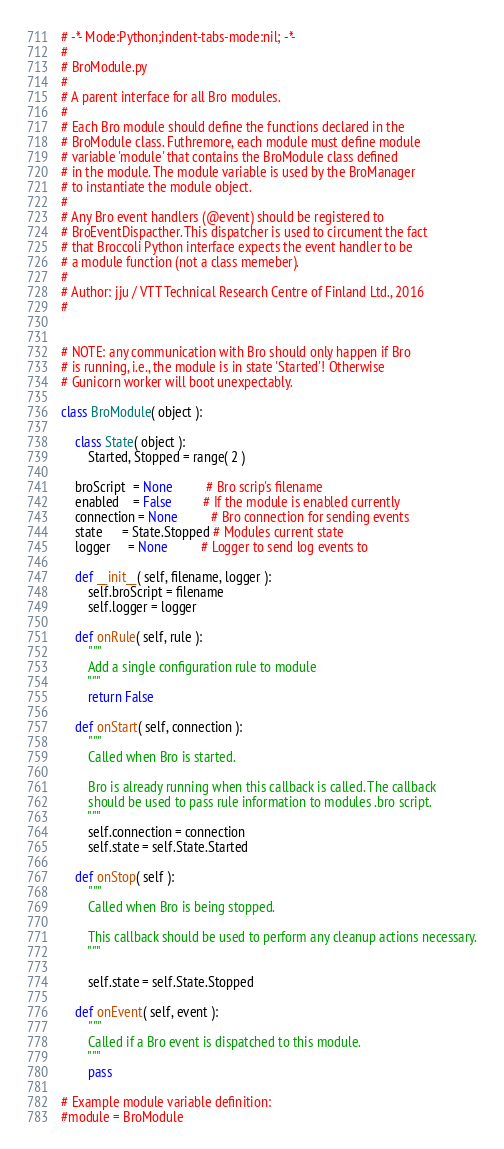Convert code to text. <code><loc_0><loc_0><loc_500><loc_500><_Python_># -*- Mode:Python;indent-tabs-mode:nil; -*-
#
# BroModule.py
#
# A parent interface for all Bro modules.
#
# Each Bro module should define the functions declared in the
# BroModule class. Futhremore, each module must define module
# variable 'module' that contains the BroModule class defined
# in the module. The module variable is used by the BroManager
# to instantiate the module object.
#
# Any Bro event handlers (@event) should be registered to
# BroEventDispacther. This dispatcher is used to circument the fact
# that Broccoli Python interface expects the event handler to be
# a module function (not a class memeber).
#
# Author: jju / VTT Technical Research Centre of Finland Ltd., 2016
#


# NOTE: any communication with Bro should only happen if Bro
# is running, i.e., the module is in state 'Started'! Otherwise
# Gunicorn worker will boot unexpectably.

class BroModule( object ):

    class State( object ):
        Started, Stopped = range( 2 )

    broScript  = None          # Bro scrip's filename
    enabled    = False         # If the module is enabled currently
    connection = None          # Bro connection for sending events
    state      = State.Stopped # Modules current state
    logger     = None          # Logger to send log events to

    def __init__( self, filename, logger ):
        self.broScript = filename
        self.logger = logger

    def onRule( self, rule ):
        """
        Add a single configuration rule to module
        """
        return False

    def onStart( self, connection ):
        """
        Called when Bro is started.

        Bro is already running when this callback is called. The callback
        should be used to pass rule information to modules .bro script.
        """
        self.connection = connection
        self.state = self.State.Started

    def onStop( self ):
        """
        Called when Bro is being stopped.

        This callback should be used to perform any cleanup actions necessary.
        """

        self.state = self.State.Stopped

    def onEvent( self, event ):
        """
        Called if a Bro event is dispatched to this module.
        """
        pass

# Example module variable definition:
#module = BroModule
</code> 